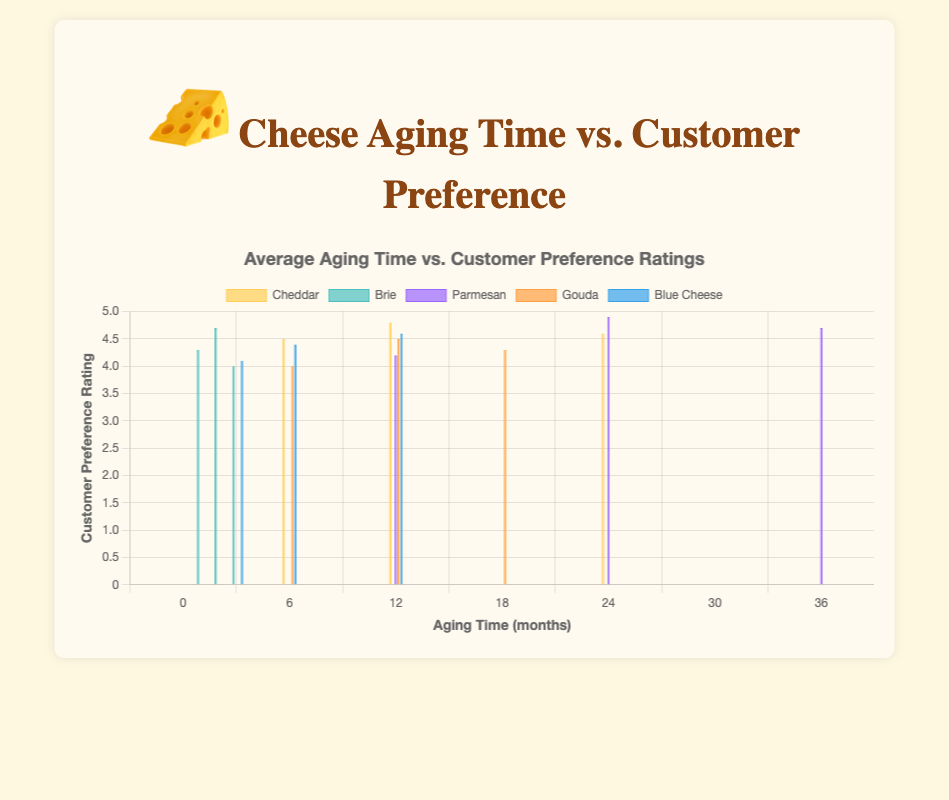Which type of cheese has the highest overall customer preference rating? Observing the chart, Parmesan aged 24 months has the highest preference rating of 4.9.
Answer: Parmesan For Blue Cheese, which aging time has the highest preference rating? Looking at the Blue Cheese bars, the 12-month aging time has the highest rating of 4.6.
Answer: 12 months Which cheese type has the lowest customer preference rating and what is the value? Brie aged 3 months has the lowest rating of 4.0.
Answer: Brie, 4.0 How does the customer preference rating for Cheddar change as the aging time increases from 6 to 24 months? For Cheddar, the ratings are 4.5 at 6 months, 4.8 at 12 months, and 4.6 at 24 months. The rating increases from 4.5 to 4.8 between 6 and 12 months, then decreases slightly to 4.6 at 24 months.
Answer: Increases then decreases Comparing 12-month aged cheeses, which type is most preferred and which is least preferred? For 12-month aging times: Cheddar is rated 4.8, Parmesan 4.2, Gouda 4.5, and Blue Cheese 4.6. Therefore, Cheddar is the most preferred and Parmesan the least preferred.
Answer: Cheddar, Parmesan What's the average customer rating for Gouda across all its aging times? Gouda ratings are 4.0 (6 months), 4.5 (12 months), and 4.3 (18 months). The average is (4.0 + 4.5 + 4.3) / 3 = 4.3.
Answer: 4.3 Which cheese type shows a consistent increase in customer preference rating with aging time? Blue Cheese has ratings of 4.1 (3 months), 4.4 (6 months), and 4.6 (12 months), showing a consistent increase.
Answer: Blue Cheese Does the longest aged Parmesan have a higher preference rating than the longest aged Cheddar? The longest aged Parmesan (36 months) has a rating of 4.7, while the longest aged Cheddar (24 months) has a rating of 4.6.
Answer: Yes What is the difference in customer preference ratings between the highest-rated Cheddar and the highest-rated Brie? The highest-rated Cheddar (12 months) is 4.8, and the highest-rated Brie (2 months) is 4.7. The difference is 4.8 - 4.7 = 0.1.
Answer: 0.1 Among all cheeses, which aging time had the most instances with customer preference ratings of 4.5 or above? Cheddar (12 months, 4.8; 24 months, 4.6), Parmesan (24 months, 4.9; 36 months, 4.7), Gouda (12 months, 4.5), Blue Cheese (12 months, 4.6) have ratings of 4.5 or above, totaling to Cheddar 2, Parmesan 2, Gouda 1, Blue Cheese 1.
Answer: Cheddar, Parmesan 